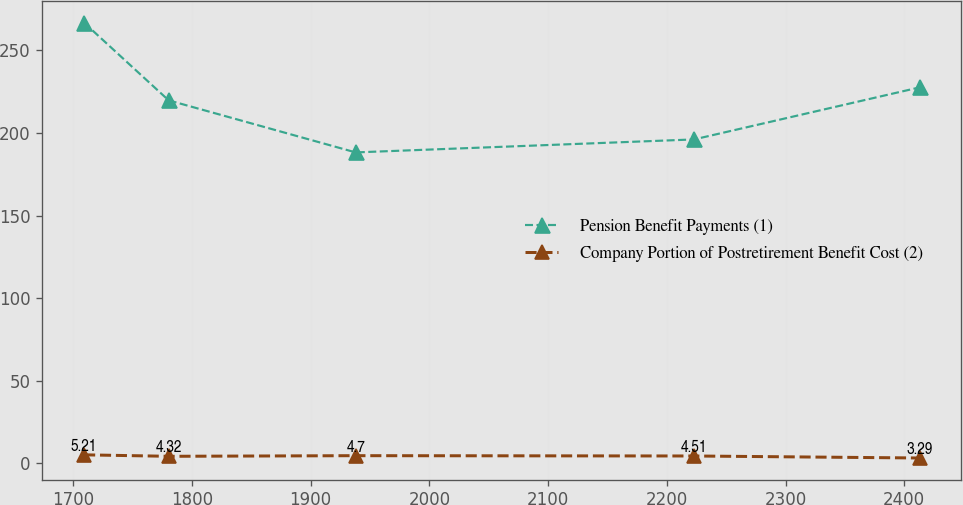Convert chart. <chart><loc_0><loc_0><loc_500><loc_500><line_chart><ecel><fcel>Pension Benefit Payments (1)<fcel>Company Portion of Postretirement Benefit Cost (2)<nl><fcel>1709.18<fcel>266.63<fcel>5.21<nl><fcel>1780.41<fcel>219.66<fcel>4.32<nl><fcel>1937.89<fcel>188.17<fcel>4.7<nl><fcel>2222.84<fcel>196.02<fcel>4.51<nl><fcel>2412.95<fcel>227.51<fcel>3.29<nl></chart> 